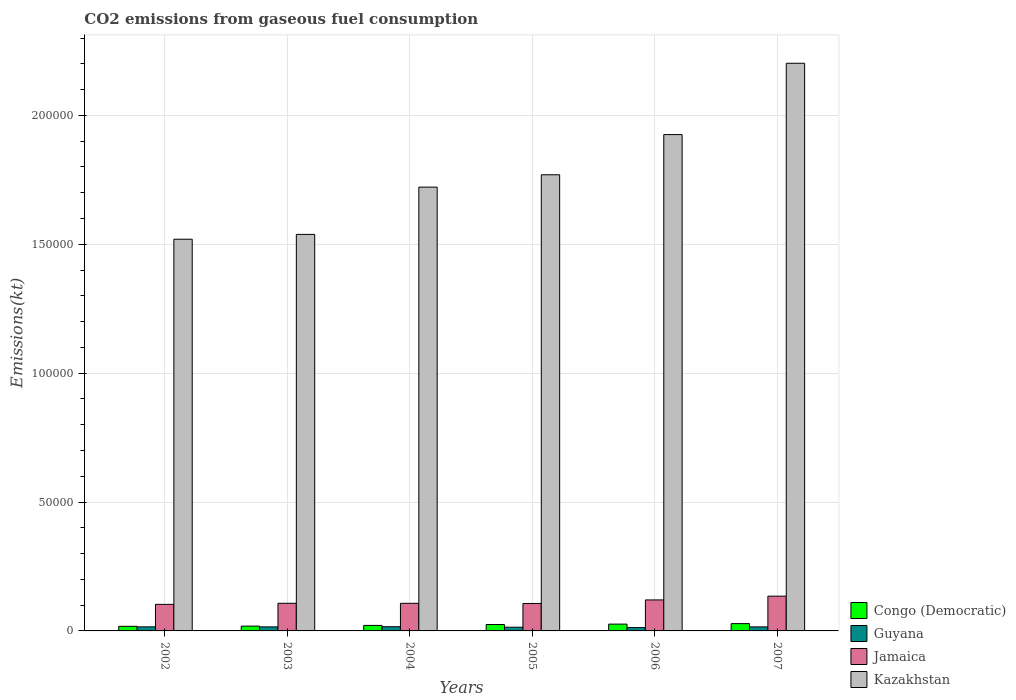How many different coloured bars are there?
Provide a succinct answer. 4. How many bars are there on the 5th tick from the right?
Your answer should be compact. 4. What is the label of the 5th group of bars from the left?
Make the answer very short. 2006. What is the amount of CO2 emitted in Congo (Democratic) in 2005?
Keep it short and to the point. 2486.23. Across all years, what is the maximum amount of CO2 emitted in Guyana?
Give a very brief answer. 1628.15. Across all years, what is the minimum amount of CO2 emitted in Kazakhstan?
Make the answer very short. 1.52e+05. In which year was the amount of CO2 emitted in Jamaica maximum?
Offer a terse response. 2007. What is the total amount of CO2 emitted in Congo (Democratic) in the graph?
Your response must be concise. 1.37e+04. What is the difference between the amount of CO2 emitted in Congo (Democratic) in 2005 and that in 2007?
Your answer should be very brief. -344.7. What is the difference between the amount of CO2 emitted in Guyana in 2006 and the amount of CO2 emitted in Jamaica in 2002?
Make the answer very short. -9009.82. What is the average amount of CO2 emitted in Congo (Democratic) per year?
Provide a short and direct response. 2290.04. In the year 2006, what is the difference between the amount of CO2 emitted in Congo (Democratic) and amount of CO2 emitted in Kazakhstan?
Your response must be concise. -1.90e+05. What is the ratio of the amount of CO2 emitted in Jamaica in 2003 to that in 2004?
Your answer should be very brief. 1. Is the difference between the amount of CO2 emitted in Congo (Democratic) in 2004 and 2005 greater than the difference between the amount of CO2 emitted in Kazakhstan in 2004 and 2005?
Offer a very short reply. Yes. What is the difference between the highest and the second highest amount of CO2 emitted in Jamaica?
Your response must be concise. 1459.47. What is the difference between the highest and the lowest amount of CO2 emitted in Congo (Democratic)?
Give a very brief answer. 1048.76. In how many years, is the amount of CO2 emitted in Congo (Democratic) greater than the average amount of CO2 emitted in Congo (Democratic) taken over all years?
Give a very brief answer. 3. Is the sum of the amount of CO2 emitted in Congo (Democratic) in 2003 and 2006 greater than the maximum amount of CO2 emitted in Guyana across all years?
Your answer should be compact. Yes. Is it the case that in every year, the sum of the amount of CO2 emitted in Jamaica and amount of CO2 emitted in Guyana is greater than the sum of amount of CO2 emitted in Congo (Democratic) and amount of CO2 emitted in Kazakhstan?
Make the answer very short. No. What does the 3rd bar from the left in 2005 represents?
Ensure brevity in your answer.  Jamaica. What does the 1st bar from the right in 2006 represents?
Offer a terse response. Kazakhstan. Is it the case that in every year, the sum of the amount of CO2 emitted in Jamaica and amount of CO2 emitted in Congo (Democratic) is greater than the amount of CO2 emitted in Guyana?
Your response must be concise. Yes. How many bars are there?
Provide a short and direct response. 24. Are all the bars in the graph horizontal?
Make the answer very short. No. How many years are there in the graph?
Your response must be concise. 6. What is the difference between two consecutive major ticks on the Y-axis?
Make the answer very short. 5.00e+04. Are the values on the major ticks of Y-axis written in scientific E-notation?
Provide a succinct answer. No. Does the graph contain any zero values?
Keep it short and to the point. No. Does the graph contain grids?
Keep it short and to the point. Yes. How are the legend labels stacked?
Offer a very short reply. Vertical. What is the title of the graph?
Offer a terse response. CO2 emissions from gaseous fuel consumption. Does "Namibia" appear as one of the legend labels in the graph?
Ensure brevity in your answer.  No. What is the label or title of the X-axis?
Provide a short and direct response. Years. What is the label or title of the Y-axis?
Your answer should be compact. Emissions(kt). What is the Emissions(kt) of Congo (Democratic) in 2002?
Give a very brief answer. 1782.16. What is the Emissions(kt) in Guyana in 2002?
Ensure brevity in your answer.  1580.48. What is the Emissions(kt) in Jamaica in 2002?
Ensure brevity in your answer.  1.03e+04. What is the Emissions(kt) in Kazakhstan in 2002?
Make the answer very short. 1.52e+05. What is the Emissions(kt) of Congo (Democratic) in 2003?
Keep it short and to the point. 1862.84. What is the Emissions(kt) in Guyana in 2003?
Your response must be concise. 1565.81. What is the Emissions(kt) in Jamaica in 2003?
Provide a short and direct response. 1.07e+04. What is the Emissions(kt) in Kazakhstan in 2003?
Your answer should be compact. 1.54e+05. What is the Emissions(kt) of Congo (Democratic) in 2004?
Offer a very short reply. 2137.86. What is the Emissions(kt) of Guyana in 2004?
Your answer should be very brief. 1628.15. What is the Emissions(kt) in Jamaica in 2004?
Your answer should be compact. 1.07e+04. What is the Emissions(kt) in Kazakhstan in 2004?
Make the answer very short. 1.72e+05. What is the Emissions(kt) in Congo (Democratic) in 2005?
Your answer should be very brief. 2486.23. What is the Emissions(kt) of Guyana in 2005?
Keep it short and to the point. 1437.46. What is the Emissions(kt) of Jamaica in 2005?
Keep it short and to the point. 1.06e+04. What is the Emissions(kt) in Kazakhstan in 2005?
Offer a very short reply. 1.77e+05. What is the Emissions(kt) in Congo (Democratic) in 2006?
Make the answer very short. 2640.24. What is the Emissions(kt) of Guyana in 2006?
Your response must be concise. 1290.78. What is the Emissions(kt) of Jamaica in 2006?
Ensure brevity in your answer.  1.20e+04. What is the Emissions(kt) of Kazakhstan in 2006?
Keep it short and to the point. 1.93e+05. What is the Emissions(kt) in Congo (Democratic) in 2007?
Provide a succinct answer. 2830.92. What is the Emissions(kt) in Guyana in 2007?
Give a very brief answer. 1562.14. What is the Emissions(kt) of Jamaica in 2007?
Provide a succinct answer. 1.35e+04. What is the Emissions(kt) in Kazakhstan in 2007?
Provide a short and direct response. 2.20e+05. Across all years, what is the maximum Emissions(kt) in Congo (Democratic)?
Your response must be concise. 2830.92. Across all years, what is the maximum Emissions(kt) of Guyana?
Make the answer very short. 1628.15. Across all years, what is the maximum Emissions(kt) of Jamaica?
Give a very brief answer. 1.35e+04. Across all years, what is the maximum Emissions(kt) in Kazakhstan?
Your answer should be compact. 2.20e+05. Across all years, what is the minimum Emissions(kt) of Congo (Democratic)?
Your answer should be very brief. 1782.16. Across all years, what is the minimum Emissions(kt) in Guyana?
Make the answer very short. 1290.78. Across all years, what is the minimum Emissions(kt) in Jamaica?
Offer a very short reply. 1.03e+04. Across all years, what is the minimum Emissions(kt) in Kazakhstan?
Offer a terse response. 1.52e+05. What is the total Emissions(kt) in Congo (Democratic) in the graph?
Your response must be concise. 1.37e+04. What is the total Emissions(kt) in Guyana in the graph?
Ensure brevity in your answer.  9064.82. What is the total Emissions(kt) in Jamaica in the graph?
Your answer should be very brief. 6.79e+04. What is the total Emissions(kt) of Kazakhstan in the graph?
Make the answer very short. 1.07e+06. What is the difference between the Emissions(kt) of Congo (Democratic) in 2002 and that in 2003?
Your answer should be compact. -80.67. What is the difference between the Emissions(kt) of Guyana in 2002 and that in 2003?
Your answer should be compact. 14.67. What is the difference between the Emissions(kt) of Jamaica in 2002 and that in 2003?
Your answer should be very brief. -421.7. What is the difference between the Emissions(kt) in Kazakhstan in 2002 and that in 2003?
Keep it short and to the point. -1870.17. What is the difference between the Emissions(kt) of Congo (Democratic) in 2002 and that in 2004?
Ensure brevity in your answer.  -355.7. What is the difference between the Emissions(kt) of Guyana in 2002 and that in 2004?
Your answer should be compact. -47.67. What is the difference between the Emissions(kt) in Jamaica in 2002 and that in 2004?
Make the answer very short. -414.37. What is the difference between the Emissions(kt) of Kazakhstan in 2002 and that in 2004?
Keep it short and to the point. -2.02e+04. What is the difference between the Emissions(kt) of Congo (Democratic) in 2002 and that in 2005?
Offer a very short reply. -704.06. What is the difference between the Emissions(kt) of Guyana in 2002 and that in 2005?
Provide a short and direct response. 143.01. What is the difference between the Emissions(kt) of Jamaica in 2002 and that in 2005?
Your answer should be compact. -344.7. What is the difference between the Emissions(kt) in Kazakhstan in 2002 and that in 2005?
Keep it short and to the point. -2.50e+04. What is the difference between the Emissions(kt) of Congo (Democratic) in 2002 and that in 2006?
Offer a terse response. -858.08. What is the difference between the Emissions(kt) of Guyana in 2002 and that in 2006?
Provide a succinct answer. 289.69. What is the difference between the Emissions(kt) of Jamaica in 2002 and that in 2006?
Your answer should be compact. -1719.82. What is the difference between the Emissions(kt) of Kazakhstan in 2002 and that in 2006?
Offer a terse response. -4.06e+04. What is the difference between the Emissions(kt) of Congo (Democratic) in 2002 and that in 2007?
Make the answer very short. -1048.76. What is the difference between the Emissions(kt) in Guyana in 2002 and that in 2007?
Your answer should be very brief. 18.34. What is the difference between the Emissions(kt) of Jamaica in 2002 and that in 2007?
Provide a short and direct response. -3179.29. What is the difference between the Emissions(kt) in Kazakhstan in 2002 and that in 2007?
Ensure brevity in your answer.  -6.83e+04. What is the difference between the Emissions(kt) of Congo (Democratic) in 2003 and that in 2004?
Give a very brief answer. -275.02. What is the difference between the Emissions(kt) in Guyana in 2003 and that in 2004?
Make the answer very short. -62.34. What is the difference between the Emissions(kt) of Jamaica in 2003 and that in 2004?
Your answer should be very brief. 7.33. What is the difference between the Emissions(kt) in Kazakhstan in 2003 and that in 2004?
Make the answer very short. -1.83e+04. What is the difference between the Emissions(kt) in Congo (Democratic) in 2003 and that in 2005?
Provide a short and direct response. -623.39. What is the difference between the Emissions(kt) in Guyana in 2003 and that in 2005?
Your response must be concise. 128.34. What is the difference between the Emissions(kt) of Jamaica in 2003 and that in 2005?
Ensure brevity in your answer.  77.01. What is the difference between the Emissions(kt) of Kazakhstan in 2003 and that in 2005?
Provide a short and direct response. -2.31e+04. What is the difference between the Emissions(kt) in Congo (Democratic) in 2003 and that in 2006?
Make the answer very short. -777.4. What is the difference between the Emissions(kt) of Guyana in 2003 and that in 2006?
Offer a terse response. 275.02. What is the difference between the Emissions(kt) in Jamaica in 2003 and that in 2006?
Offer a terse response. -1298.12. What is the difference between the Emissions(kt) in Kazakhstan in 2003 and that in 2006?
Keep it short and to the point. -3.87e+04. What is the difference between the Emissions(kt) of Congo (Democratic) in 2003 and that in 2007?
Provide a succinct answer. -968.09. What is the difference between the Emissions(kt) of Guyana in 2003 and that in 2007?
Offer a very short reply. 3.67. What is the difference between the Emissions(kt) in Jamaica in 2003 and that in 2007?
Your response must be concise. -2757.58. What is the difference between the Emissions(kt) of Kazakhstan in 2003 and that in 2007?
Give a very brief answer. -6.64e+04. What is the difference between the Emissions(kt) in Congo (Democratic) in 2004 and that in 2005?
Provide a succinct answer. -348.37. What is the difference between the Emissions(kt) in Guyana in 2004 and that in 2005?
Keep it short and to the point. 190.68. What is the difference between the Emissions(kt) of Jamaica in 2004 and that in 2005?
Provide a succinct answer. 69.67. What is the difference between the Emissions(kt) in Kazakhstan in 2004 and that in 2005?
Offer a terse response. -4789.1. What is the difference between the Emissions(kt) of Congo (Democratic) in 2004 and that in 2006?
Offer a very short reply. -502.38. What is the difference between the Emissions(kt) in Guyana in 2004 and that in 2006?
Offer a terse response. 337.36. What is the difference between the Emissions(kt) of Jamaica in 2004 and that in 2006?
Offer a very short reply. -1305.45. What is the difference between the Emissions(kt) of Kazakhstan in 2004 and that in 2006?
Provide a short and direct response. -2.04e+04. What is the difference between the Emissions(kt) of Congo (Democratic) in 2004 and that in 2007?
Offer a very short reply. -693.06. What is the difference between the Emissions(kt) of Guyana in 2004 and that in 2007?
Keep it short and to the point. 66.01. What is the difference between the Emissions(kt) in Jamaica in 2004 and that in 2007?
Offer a very short reply. -2764.92. What is the difference between the Emissions(kt) of Kazakhstan in 2004 and that in 2007?
Provide a succinct answer. -4.80e+04. What is the difference between the Emissions(kt) of Congo (Democratic) in 2005 and that in 2006?
Offer a terse response. -154.01. What is the difference between the Emissions(kt) in Guyana in 2005 and that in 2006?
Your answer should be compact. 146.68. What is the difference between the Emissions(kt) in Jamaica in 2005 and that in 2006?
Offer a very short reply. -1375.12. What is the difference between the Emissions(kt) of Kazakhstan in 2005 and that in 2006?
Offer a very short reply. -1.56e+04. What is the difference between the Emissions(kt) of Congo (Democratic) in 2005 and that in 2007?
Your answer should be compact. -344.7. What is the difference between the Emissions(kt) in Guyana in 2005 and that in 2007?
Make the answer very short. -124.68. What is the difference between the Emissions(kt) in Jamaica in 2005 and that in 2007?
Provide a short and direct response. -2834.59. What is the difference between the Emissions(kt) of Kazakhstan in 2005 and that in 2007?
Provide a succinct answer. -4.33e+04. What is the difference between the Emissions(kt) of Congo (Democratic) in 2006 and that in 2007?
Offer a very short reply. -190.68. What is the difference between the Emissions(kt) of Guyana in 2006 and that in 2007?
Your answer should be compact. -271.36. What is the difference between the Emissions(kt) in Jamaica in 2006 and that in 2007?
Make the answer very short. -1459.47. What is the difference between the Emissions(kt) of Kazakhstan in 2006 and that in 2007?
Provide a succinct answer. -2.77e+04. What is the difference between the Emissions(kt) in Congo (Democratic) in 2002 and the Emissions(kt) in Guyana in 2003?
Your answer should be very brief. 216.35. What is the difference between the Emissions(kt) of Congo (Democratic) in 2002 and the Emissions(kt) of Jamaica in 2003?
Your response must be concise. -8940.15. What is the difference between the Emissions(kt) in Congo (Democratic) in 2002 and the Emissions(kt) in Kazakhstan in 2003?
Your response must be concise. -1.52e+05. What is the difference between the Emissions(kt) of Guyana in 2002 and the Emissions(kt) of Jamaica in 2003?
Your answer should be very brief. -9141.83. What is the difference between the Emissions(kt) of Guyana in 2002 and the Emissions(kt) of Kazakhstan in 2003?
Provide a short and direct response. -1.52e+05. What is the difference between the Emissions(kt) in Jamaica in 2002 and the Emissions(kt) in Kazakhstan in 2003?
Provide a short and direct response. -1.44e+05. What is the difference between the Emissions(kt) of Congo (Democratic) in 2002 and the Emissions(kt) of Guyana in 2004?
Your answer should be very brief. 154.01. What is the difference between the Emissions(kt) in Congo (Democratic) in 2002 and the Emissions(kt) in Jamaica in 2004?
Keep it short and to the point. -8932.81. What is the difference between the Emissions(kt) of Congo (Democratic) in 2002 and the Emissions(kt) of Kazakhstan in 2004?
Your answer should be very brief. -1.70e+05. What is the difference between the Emissions(kt) in Guyana in 2002 and the Emissions(kt) in Jamaica in 2004?
Your answer should be compact. -9134.5. What is the difference between the Emissions(kt) of Guyana in 2002 and the Emissions(kt) of Kazakhstan in 2004?
Your answer should be very brief. -1.71e+05. What is the difference between the Emissions(kt) of Jamaica in 2002 and the Emissions(kt) of Kazakhstan in 2004?
Your response must be concise. -1.62e+05. What is the difference between the Emissions(kt) of Congo (Democratic) in 2002 and the Emissions(kt) of Guyana in 2005?
Give a very brief answer. 344.7. What is the difference between the Emissions(kt) in Congo (Democratic) in 2002 and the Emissions(kt) in Jamaica in 2005?
Your answer should be very brief. -8863.14. What is the difference between the Emissions(kt) of Congo (Democratic) in 2002 and the Emissions(kt) of Kazakhstan in 2005?
Your answer should be compact. -1.75e+05. What is the difference between the Emissions(kt) in Guyana in 2002 and the Emissions(kt) in Jamaica in 2005?
Provide a succinct answer. -9064.82. What is the difference between the Emissions(kt) of Guyana in 2002 and the Emissions(kt) of Kazakhstan in 2005?
Provide a succinct answer. -1.75e+05. What is the difference between the Emissions(kt) in Jamaica in 2002 and the Emissions(kt) in Kazakhstan in 2005?
Your answer should be very brief. -1.67e+05. What is the difference between the Emissions(kt) in Congo (Democratic) in 2002 and the Emissions(kt) in Guyana in 2006?
Your answer should be compact. 491.38. What is the difference between the Emissions(kt) in Congo (Democratic) in 2002 and the Emissions(kt) in Jamaica in 2006?
Ensure brevity in your answer.  -1.02e+04. What is the difference between the Emissions(kt) in Congo (Democratic) in 2002 and the Emissions(kt) in Kazakhstan in 2006?
Give a very brief answer. -1.91e+05. What is the difference between the Emissions(kt) of Guyana in 2002 and the Emissions(kt) of Jamaica in 2006?
Offer a terse response. -1.04e+04. What is the difference between the Emissions(kt) in Guyana in 2002 and the Emissions(kt) in Kazakhstan in 2006?
Offer a terse response. -1.91e+05. What is the difference between the Emissions(kt) of Jamaica in 2002 and the Emissions(kt) of Kazakhstan in 2006?
Offer a terse response. -1.82e+05. What is the difference between the Emissions(kt) of Congo (Democratic) in 2002 and the Emissions(kt) of Guyana in 2007?
Provide a succinct answer. 220.02. What is the difference between the Emissions(kt) of Congo (Democratic) in 2002 and the Emissions(kt) of Jamaica in 2007?
Provide a succinct answer. -1.17e+04. What is the difference between the Emissions(kt) of Congo (Democratic) in 2002 and the Emissions(kt) of Kazakhstan in 2007?
Offer a terse response. -2.18e+05. What is the difference between the Emissions(kt) in Guyana in 2002 and the Emissions(kt) in Jamaica in 2007?
Offer a terse response. -1.19e+04. What is the difference between the Emissions(kt) in Guyana in 2002 and the Emissions(kt) in Kazakhstan in 2007?
Keep it short and to the point. -2.19e+05. What is the difference between the Emissions(kt) of Jamaica in 2002 and the Emissions(kt) of Kazakhstan in 2007?
Give a very brief answer. -2.10e+05. What is the difference between the Emissions(kt) of Congo (Democratic) in 2003 and the Emissions(kt) of Guyana in 2004?
Ensure brevity in your answer.  234.69. What is the difference between the Emissions(kt) in Congo (Democratic) in 2003 and the Emissions(kt) in Jamaica in 2004?
Your answer should be compact. -8852.14. What is the difference between the Emissions(kt) in Congo (Democratic) in 2003 and the Emissions(kt) in Kazakhstan in 2004?
Offer a very short reply. -1.70e+05. What is the difference between the Emissions(kt) of Guyana in 2003 and the Emissions(kt) of Jamaica in 2004?
Offer a very short reply. -9149.17. What is the difference between the Emissions(kt) in Guyana in 2003 and the Emissions(kt) in Kazakhstan in 2004?
Provide a short and direct response. -1.71e+05. What is the difference between the Emissions(kt) in Jamaica in 2003 and the Emissions(kt) in Kazakhstan in 2004?
Provide a succinct answer. -1.61e+05. What is the difference between the Emissions(kt) of Congo (Democratic) in 2003 and the Emissions(kt) of Guyana in 2005?
Offer a very short reply. 425.37. What is the difference between the Emissions(kt) in Congo (Democratic) in 2003 and the Emissions(kt) in Jamaica in 2005?
Your answer should be very brief. -8782.47. What is the difference between the Emissions(kt) of Congo (Democratic) in 2003 and the Emissions(kt) of Kazakhstan in 2005?
Offer a terse response. -1.75e+05. What is the difference between the Emissions(kt) of Guyana in 2003 and the Emissions(kt) of Jamaica in 2005?
Your answer should be very brief. -9079.49. What is the difference between the Emissions(kt) in Guyana in 2003 and the Emissions(kt) in Kazakhstan in 2005?
Keep it short and to the point. -1.75e+05. What is the difference between the Emissions(kt) in Jamaica in 2003 and the Emissions(kt) in Kazakhstan in 2005?
Offer a terse response. -1.66e+05. What is the difference between the Emissions(kt) of Congo (Democratic) in 2003 and the Emissions(kt) of Guyana in 2006?
Provide a succinct answer. 572.05. What is the difference between the Emissions(kt) in Congo (Democratic) in 2003 and the Emissions(kt) in Jamaica in 2006?
Offer a terse response. -1.02e+04. What is the difference between the Emissions(kt) in Congo (Democratic) in 2003 and the Emissions(kt) in Kazakhstan in 2006?
Your answer should be very brief. -1.91e+05. What is the difference between the Emissions(kt) in Guyana in 2003 and the Emissions(kt) in Jamaica in 2006?
Provide a short and direct response. -1.05e+04. What is the difference between the Emissions(kt) of Guyana in 2003 and the Emissions(kt) of Kazakhstan in 2006?
Your answer should be very brief. -1.91e+05. What is the difference between the Emissions(kt) in Jamaica in 2003 and the Emissions(kt) in Kazakhstan in 2006?
Your answer should be very brief. -1.82e+05. What is the difference between the Emissions(kt) in Congo (Democratic) in 2003 and the Emissions(kt) in Guyana in 2007?
Your answer should be very brief. 300.69. What is the difference between the Emissions(kt) of Congo (Democratic) in 2003 and the Emissions(kt) of Jamaica in 2007?
Offer a terse response. -1.16e+04. What is the difference between the Emissions(kt) in Congo (Democratic) in 2003 and the Emissions(kt) in Kazakhstan in 2007?
Provide a short and direct response. -2.18e+05. What is the difference between the Emissions(kt) of Guyana in 2003 and the Emissions(kt) of Jamaica in 2007?
Offer a terse response. -1.19e+04. What is the difference between the Emissions(kt) in Guyana in 2003 and the Emissions(kt) in Kazakhstan in 2007?
Your answer should be very brief. -2.19e+05. What is the difference between the Emissions(kt) in Jamaica in 2003 and the Emissions(kt) in Kazakhstan in 2007?
Offer a terse response. -2.09e+05. What is the difference between the Emissions(kt) in Congo (Democratic) in 2004 and the Emissions(kt) in Guyana in 2005?
Make the answer very short. 700.4. What is the difference between the Emissions(kt) of Congo (Democratic) in 2004 and the Emissions(kt) of Jamaica in 2005?
Provide a succinct answer. -8507.44. What is the difference between the Emissions(kt) of Congo (Democratic) in 2004 and the Emissions(kt) of Kazakhstan in 2005?
Make the answer very short. -1.75e+05. What is the difference between the Emissions(kt) in Guyana in 2004 and the Emissions(kt) in Jamaica in 2005?
Give a very brief answer. -9017.15. What is the difference between the Emissions(kt) in Guyana in 2004 and the Emissions(kt) in Kazakhstan in 2005?
Your answer should be compact. -1.75e+05. What is the difference between the Emissions(kt) of Jamaica in 2004 and the Emissions(kt) of Kazakhstan in 2005?
Offer a terse response. -1.66e+05. What is the difference between the Emissions(kt) of Congo (Democratic) in 2004 and the Emissions(kt) of Guyana in 2006?
Keep it short and to the point. 847.08. What is the difference between the Emissions(kt) of Congo (Democratic) in 2004 and the Emissions(kt) of Jamaica in 2006?
Your answer should be very brief. -9882.57. What is the difference between the Emissions(kt) of Congo (Democratic) in 2004 and the Emissions(kt) of Kazakhstan in 2006?
Ensure brevity in your answer.  -1.90e+05. What is the difference between the Emissions(kt) in Guyana in 2004 and the Emissions(kt) in Jamaica in 2006?
Ensure brevity in your answer.  -1.04e+04. What is the difference between the Emissions(kt) in Guyana in 2004 and the Emissions(kt) in Kazakhstan in 2006?
Your answer should be compact. -1.91e+05. What is the difference between the Emissions(kt) in Jamaica in 2004 and the Emissions(kt) in Kazakhstan in 2006?
Provide a short and direct response. -1.82e+05. What is the difference between the Emissions(kt) of Congo (Democratic) in 2004 and the Emissions(kt) of Guyana in 2007?
Offer a very short reply. 575.72. What is the difference between the Emissions(kt) in Congo (Democratic) in 2004 and the Emissions(kt) in Jamaica in 2007?
Your answer should be compact. -1.13e+04. What is the difference between the Emissions(kt) of Congo (Democratic) in 2004 and the Emissions(kt) of Kazakhstan in 2007?
Provide a short and direct response. -2.18e+05. What is the difference between the Emissions(kt) of Guyana in 2004 and the Emissions(kt) of Jamaica in 2007?
Ensure brevity in your answer.  -1.19e+04. What is the difference between the Emissions(kt) of Guyana in 2004 and the Emissions(kt) of Kazakhstan in 2007?
Offer a terse response. -2.19e+05. What is the difference between the Emissions(kt) of Jamaica in 2004 and the Emissions(kt) of Kazakhstan in 2007?
Provide a short and direct response. -2.09e+05. What is the difference between the Emissions(kt) of Congo (Democratic) in 2005 and the Emissions(kt) of Guyana in 2006?
Offer a very short reply. 1195.44. What is the difference between the Emissions(kt) in Congo (Democratic) in 2005 and the Emissions(kt) in Jamaica in 2006?
Make the answer very short. -9534.2. What is the difference between the Emissions(kt) of Congo (Democratic) in 2005 and the Emissions(kt) of Kazakhstan in 2006?
Offer a very short reply. -1.90e+05. What is the difference between the Emissions(kt) of Guyana in 2005 and the Emissions(kt) of Jamaica in 2006?
Your answer should be very brief. -1.06e+04. What is the difference between the Emissions(kt) of Guyana in 2005 and the Emissions(kt) of Kazakhstan in 2006?
Keep it short and to the point. -1.91e+05. What is the difference between the Emissions(kt) of Jamaica in 2005 and the Emissions(kt) of Kazakhstan in 2006?
Keep it short and to the point. -1.82e+05. What is the difference between the Emissions(kt) in Congo (Democratic) in 2005 and the Emissions(kt) in Guyana in 2007?
Make the answer very short. 924.08. What is the difference between the Emissions(kt) in Congo (Democratic) in 2005 and the Emissions(kt) in Jamaica in 2007?
Offer a very short reply. -1.10e+04. What is the difference between the Emissions(kt) in Congo (Democratic) in 2005 and the Emissions(kt) in Kazakhstan in 2007?
Ensure brevity in your answer.  -2.18e+05. What is the difference between the Emissions(kt) in Guyana in 2005 and the Emissions(kt) in Jamaica in 2007?
Keep it short and to the point. -1.20e+04. What is the difference between the Emissions(kt) of Guyana in 2005 and the Emissions(kt) of Kazakhstan in 2007?
Keep it short and to the point. -2.19e+05. What is the difference between the Emissions(kt) in Jamaica in 2005 and the Emissions(kt) in Kazakhstan in 2007?
Ensure brevity in your answer.  -2.10e+05. What is the difference between the Emissions(kt) in Congo (Democratic) in 2006 and the Emissions(kt) in Guyana in 2007?
Provide a succinct answer. 1078.1. What is the difference between the Emissions(kt) of Congo (Democratic) in 2006 and the Emissions(kt) of Jamaica in 2007?
Make the answer very short. -1.08e+04. What is the difference between the Emissions(kt) of Congo (Democratic) in 2006 and the Emissions(kt) of Kazakhstan in 2007?
Your response must be concise. -2.18e+05. What is the difference between the Emissions(kt) of Guyana in 2006 and the Emissions(kt) of Jamaica in 2007?
Keep it short and to the point. -1.22e+04. What is the difference between the Emissions(kt) of Guyana in 2006 and the Emissions(kt) of Kazakhstan in 2007?
Provide a short and direct response. -2.19e+05. What is the difference between the Emissions(kt) in Jamaica in 2006 and the Emissions(kt) in Kazakhstan in 2007?
Make the answer very short. -2.08e+05. What is the average Emissions(kt) in Congo (Democratic) per year?
Your answer should be very brief. 2290.04. What is the average Emissions(kt) of Guyana per year?
Provide a short and direct response. 1510.8. What is the average Emissions(kt) in Jamaica per year?
Your response must be concise. 1.13e+04. What is the average Emissions(kt) of Kazakhstan per year?
Give a very brief answer. 1.78e+05. In the year 2002, what is the difference between the Emissions(kt) of Congo (Democratic) and Emissions(kt) of Guyana?
Make the answer very short. 201.69. In the year 2002, what is the difference between the Emissions(kt) of Congo (Democratic) and Emissions(kt) of Jamaica?
Your answer should be very brief. -8518.44. In the year 2002, what is the difference between the Emissions(kt) of Congo (Democratic) and Emissions(kt) of Kazakhstan?
Keep it short and to the point. -1.50e+05. In the year 2002, what is the difference between the Emissions(kt) in Guyana and Emissions(kt) in Jamaica?
Provide a short and direct response. -8720.13. In the year 2002, what is the difference between the Emissions(kt) of Guyana and Emissions(kt) of Kazakhstan?
Make the answer very short. -1.50e+05. In the year 2002, what is the difference between the Emissions(kt) in Jamaica and Emissions(kt) in Kazakhstan?
Give a very brief answer. -1.42e+05. In the year 2003, what is the difference between the Emissions(kt) of Congo (Democratic) and Emissions(kt) of Guyana?
Your answer should be very brief. 297.03. In the year 2003, what is the difference between the Emissions(kt) in Congo (Democratic) and Emissions(kt) in Jamaica?
Your response must be concise. -8859.47. In the year 2003, what is the difference between the Emissions(kt) in Congo (Democratic) and Emissions(kt) in Kazakhstan?
Make the answer very short. -1.52e+05. In the year 2003, what is the difference between the Emissions(kt) of Guyana and Emissions(kt) of Jamaica?
Your answer should be very brief. -9156.5. In the year 2003, what is the difference between the Emissions(kt) in Guyana and Emissions(kt) in Kazakhstan?
Ensure brevity in your answer.  -1.52e+05. In the year 2003, what is the difference between the Emissions(kt) of Jamaica and Emissions(kt) of Kazakhstan?
Provide a succinct answer. -1.43e+05. In the year 2004, what is the difference between the Emissions(kt) of Congo (Democratic) and Emissions(kt) of Guyana?
Make the answer very short. 509.71. In the year 2004, what is the difference between the Emissions(kt) of Congo (Democratic) and Emissions(kt) of Jamaica?
Offer a very short reply. -8577.11. In the year 2004, what is the difference between the Emissions(kt) in Congo (Democratic) and Emissions(kt) in Kazakhstan?
Keep it short and to the point. -1.70e+05. In the year 2004, what is the difference between the Emissions(kt) in Guyana and Emissions(kt) in Jamaica?
Your response must be concise. -9086.83. In the year 2004, what is the difference between the Emissions(kt) in Guyana and Emissions(kt) in Kazakhstan?
Your response must be concise. -1.71e+05. In the year 2004, what is the difference between the Emissions(kt) of Jamaica and Emissions(kt) of Kazakhstan?
Provide a succinct answer. -1.61e+05. In the year 2005, what is the difference between the Emissions(kt) in Congo (Democratic) and Emissions(kt) in Guyana?
Offer a very short reply. 1048.76. In the year 2005, what is the difference between the Emissions(kt) in Congo (Democratic) and Emissions(kt) in Jamaica?
Give a very brief answer. -8159.07. In the year 2005, what is the difference between the Emissions(kt) in Congo (Democratic) and Emissions(kt) in Kazakhstan?
Offer a terse response. -1.74e+05. In the year 2005, what is the difference between the Emissions(kt) in Guyana and Emissions(kt) in Jamaica?
Ensure brevity in your answer.  -9207.84. In the year 2005, what is the difference between the Emissions(kt) of Guyana and Emissions(kt) of Kazakhstan?
Your answer should be compact. -1.76e+05. In the year 2005, what is the difference between the Emissions(kt) in Jamaica and Emissions(kt) in Kazakhstan?
Offer a terse response. -1.66e+05. In the year 2006, what is the difference between the Emissions(kt) of Congo (Democratic) and Emissions(kt) of Guyana?
Keep it short and to the point. 1349.46. In the year 2006, what is the difference between the Emissions(kt) in Congo (Democratic) and Emissions(kt) in Jamaica?
Keep it short and to the point. -9380.19. In the year 2006, what is the difference between the Emissions(kt) in Congo (Democratic) and Emissions(kt) in Kazakhstan?
Provide a short and direct response. -1.90e+05. In the year 2006, what is the difference between the Emissions(kt) of Guyana and Emissions(kt) of Jamaica?
Keep it short and to the point. -1.07e+04. In the year 2006, what is the difference between the Emissions(kt) in Guyana and Emissions(kt) in Kazakhstan?
Provide a short and direct response. -1.91e+05. In the year 2006, what is the difference between the Emissions(kt) of Jamaica and Emissions(kt) of Kazakhstan?
Offer a terse response. -1.81e+05. In the year 2007, what is the difference between the Emissions(kt) of Congo (Democratic) and Emissions(kt) of Guyana?
Offer a very short reply. 1268.78. In the year 2007, what is the difference between the Emissions(kt) of Congo (Democratic) and Emissions(kt) of Jamaica?
Your answer should be compact. -1.06e+04. In the year 2007, what is the difference between the Emissions(kt) in Congo (Democratic) and Emissions(kt) in Kazakhstan?
Give a very brief answer. -2.17e+05. In the year 2007, what is the difference between the Emissions(kt) of Guyana and Emissions(kt) of Jamaica?
Ensure brevity in your answer.  -1.19e+04. In the year 2007, what is the difference between the Emissions(kt) in Guyana and Emissions(kt) in Kazakhstan?
Your response must be concise. -2.19e+05. In the year 2007, what is the difference between the Emissions(kt) of Jamaica and Emissions(kt) of Kazakhstan?
Provide a succinct answer. -2.07e+05. What is the ratio of the Emissions(kt) of Congo (Democratic) in 2002 to that in 2003?
Provide a short and direct response. 0.96. What is the ratio of the Emissions(kt) in Guyana in 2002 to that in 2003?
Provide a short and direct response. 1.01. What is the ratio of the Emissions(kt) of Jamaica in 2002 to that in 2003?
Your answer should be very brief. 0.96. What is the ratio of the Emissions(kt) of Kazakhstan in 2002 to that in 2003?
Provide a short and direct response. 0.99. What is the ratio of the Emissions(kt) in Congo (Democratic) in 2002 to that in 2004?
Keep it short and to the point. 0.83. What is the ratio of the Emissions(kt) in Guyana in 2002 to that in 2004?
Offer a terse response. 0.97. What is the ratio of the Emissions(kt) of Jamaica in 2002 to that in 2004?
Make the answer very short. 0.96. What is the ratio of the Emissions(kt) of Kazakhstan in 2002 to that in 2004?
Your answer should be compact. 0.88. What is the ratio of the Emissions(kt) of Congo (Democratic) in 2002 to that in 2005?
Give a very brief answer. 0.72. What is the ratio of the Emissions(kt) in Guyana in 2002 to that in 2005?
Keep it short and to the point. 1.1. What is the ratio of the Emissions(kt) in Jamaica in 2002 to that in 2005?
Keep it short and to the point. 0.97. What is the ratio of the Emissions(kt) in Kazakhstan in 2002 to that in 2005?
Provide a short and direct response. 0.86. What is the ratio of the Emissions(kt) in Congo (Democratic) in 2002 to that in 2006?
Make the answer very short. 0.68. What is the ratio of the Emissions(kt) in Guyana in 2002 to that in 2006?
Give a very brief answer. 1.22. What is the ratio of the Emissions(kt) in Jamaica in 2002 to that in 2006?
Provide a short and direct response. 0.86. What is the ratio of the Emissions(kt) in Kazakhstan in 2002 to that in 2006?
Provide a short and direct response. 0.79. What is the ratio of the Emissions(kt) of Congo (Democratic) in 2002 to that in 2007?
Offer a very short reply. 0.63. What is the ratio of the Emissions(kt) in Guyana in 2002 to that in 2007?
Make the answer very short. 1.01. What is the ratio of the Emissions(kt) in Jamaica in 2002 to that in 2007?
Ensure brevity in your answer.  0.76. What is the ratio of the Emissions(kt) of Kazakhstan in 2002 to that in 2007?
Ensure brevity in your answer.  0.69. What is the ratio of the Emissions(kt) of Congo (Democratic) in 2003 to that in 2004?
Your answer should be compact. 0.87. What is the ratio of the Emissions(kt) in Guyana in 2003 to that in 2004?
Your answer should be compact. 0.96. What is the ratio of the Emissions(kt) in Jamaica in 2003 to that in 2004?
Your response must be concise. 1. What is the ratio of the Emissions(kt) of Kazakhstan in 2003 to that in 2004?
Your response must be concise. 0.89. What is the ratio of the Emissions(kt) in Congo (Democratic) in 2003 to that in 2005?
Provide a succinct answer. 0.75. What is the ratio of the Emissions(kt) in Guyana in 2003 to that in 2005?
Make the answer very short. 1.09. What is the ratio of the Emissions(kt) in Jamaica in 2003 to that in 2005?
Offer a very short reply. 1.01. What is the ratio of the Emissions(kt) of Kazakhstan in 2003 to that in 2005?
Provide a succinct answer. 0.87. What is the ratio of the Emissions(kt) in Congo (Democratic) in 2003 to that in 2006?
Provide a short and direct response. 0.71. What is the ratio of the Emissions(kt) of Guyana in 2003 to that in 2006?
Offer a terse response. 1.21. What is the ratio of the Emissions(kt) of Jamaica in 2003 to that in 2006?
Offer a terse response. 0.89. What is the ratio of the Emissions(kt) of Kazakhstan in 2003 to that in 2006?
Offer a very short reply. 0.8. What is the ratio of the Emissions(kt) in Congo (Democratic) in 2003 to that in 2007?
Keep it short and to the point. 0.66. What is the ratio of the Emissions(kt) in Guyana in 2003 to that in 2007?
Provide a short and direct response. 1. What is the ratio of the Emissions(kt) in Jamaica in 2003 to that in 2007?
Ensure brevity in your answer.  0.8. What is the ratio of the Emissions(kt) of Kazakhstan in 2003 to that in 2007?
Give a very brief answer. 0.7. What is the ratio of the Emissions(kt) of Congo (Democratic) in 2004 to that in 2005?
Your answer should be compact. 0.86. What is the ratio of the Emissions(kt) of Guyana in 2004 to that in 2005?
Your answer should be very brief. 1.13. What is the ratio of the Emissions(kt) of Kazakhstan in 2004 to that in 2005?
Ensure brevity in your answer.  0.97. What is the ratio of the Emissions(kt) of Congo (Democratic) in 2004 to that in 2006?
Your answer should be very brief. 0.81. What is the ratio of the Emissions(kt) in Guyana in 2004 to that in 2006?
Give a very brief answer. 1.26. What is the ratio of the Emissions(kt) of Jamaica in 2004 to that in 2006?
Make the answer very short. 0.89. What is the ratio of the Emissions(kt) in Kazakhstan in 2004 to that in 2006?
Give a very brief answer. 0.89. What is the ratio of the Emissions(kt) of Congo (Democratic) in 2004 to that in 2007?
Your answer should be compact. 0.76. What is the ratio of the Emissions(kt) in Guyana in 2004 to that in 2007?
Keep it short and to the point. 1.04. What is the ratio of the Emissions(kt) in Jamaica in 2004 to that in 2007?
Your answer should be very brief. 0.79. What is the ratio of the Emissions(kt) in Kazakhstan in 2004 to that in 2007?
Keep it short and to the point. 0.78. What is the ratio of the Emissions(kt) in Congo (Democratic) in 2005 to that in 2006?
Your answer should be very brief. 0.94. What is the ratio of the Emissions(kt) in Guyana in 2005 to that in 2006?
Keep it short and to the point. 1.11. What is the ratio of the Emissions(kt) of Jamaica in 2005 to that in 2006?
Your response must be concise. 0.89. What is the ratio of the Emissions(kt) of Kazakhstan in 2005 to that in 2006?
Your answer should be compact. 0.92. What is the ratio of the Emissions(kt) in Congo (Democratic) in 2005 to that in 2007?
Make the answer very short. 0.88. What is the ratio of the Emissions(kt) of Guyana in 2005 to that in 2007?
Give a very brief answer. 0.92. What is the ratio of the Emissions(kt) in Jamaica in 2005 to that in 2007?
Offer a very short reply. 0.79. What is the ratio of the Emissions(kt) of Kazakhstan in 2005 to that in 2007?
Make the answer very short. 0.8. What is the ratio of the Emissions(kt) of Congo (Democratic) in 2006 to that in 2007?
Offer a very short reply. 0.93. What is the ratio of the Emissions(kt) of Guyana in 2006 to that in 2007?
Offer a terse response. 0.83. What is the ratio of the Emissions(kt) in Jamaica in 2006 to that in 2007?
Your response must be concise. 0.89. What is the ratio of the Emissions(kt) in Kazakhstan in 2006 to that in 2007?
Provide a succinct answer. 0.87. What is the difference between the highest and the second highest Emissions(kt) in Congo (Democratic)?
Ensure brevity in your answer.  190.68. What is the difference between the highest and the second highest Emissions(kt) in Guyana?
Your response must be concise. 47.67. What is the difference between the highest and the second highest Emissions(kt) in Jamaica?
Give a very brief answer. 1459.47. What is the difference between the highest and the second highest Emissions(kt) of Kazakhstan?
Your answer should be very brief. 2.77e+04. What is the difference between the highest and the lowest Emissions(kt) of Congo (Democratic)?
Keep it short and to the point. 1048.76. What is the difference between the highest and the lowest Emissions(kt) in Guyana?
Offer a terse response. 337.36. What is the difference between the highest and the lowest Emissions(kt) of Jamaica?
Give a very brief answer. 3179.29. What is the difference between the highest and the lowest Emissions(kt) in Kazakhstan?
Offer a terse response. 6.83e+04. 